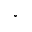<formula> <loc_0><loc_0><loc_500><loc_500>^ { \circ }</formula> 